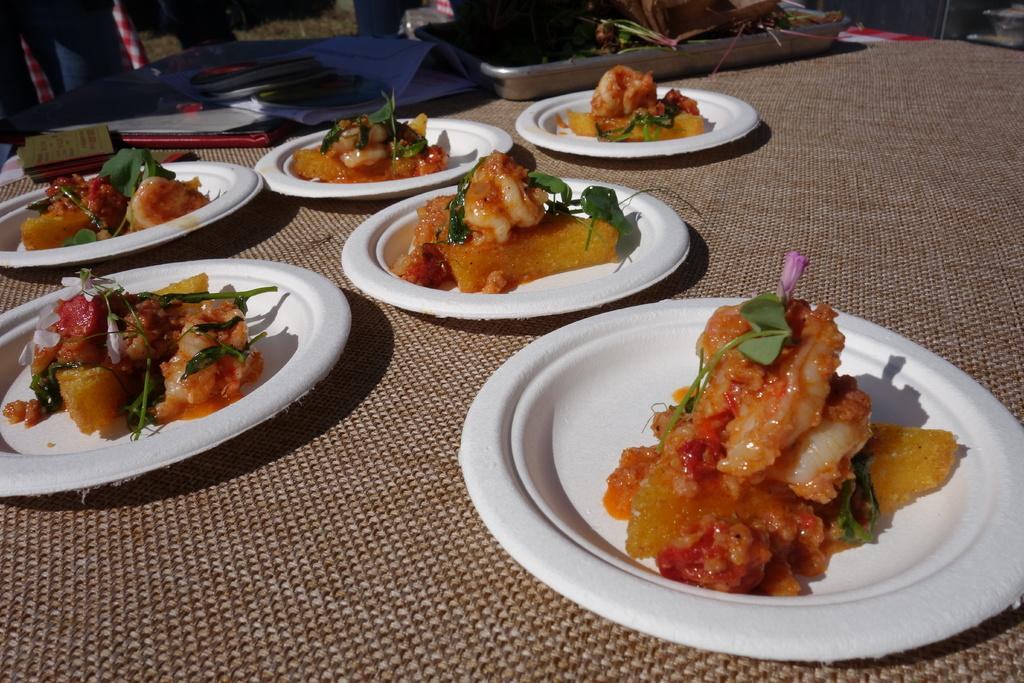What is present on the plates in the image? There is food in the plates in the image. What type of humor can be seen in the image? There is no humor present in the image; it simply shows food on plates. What kind of shade is provided by the objects in the image? There is no mention of any objects providing shade in the image; it only shows food on plates. 